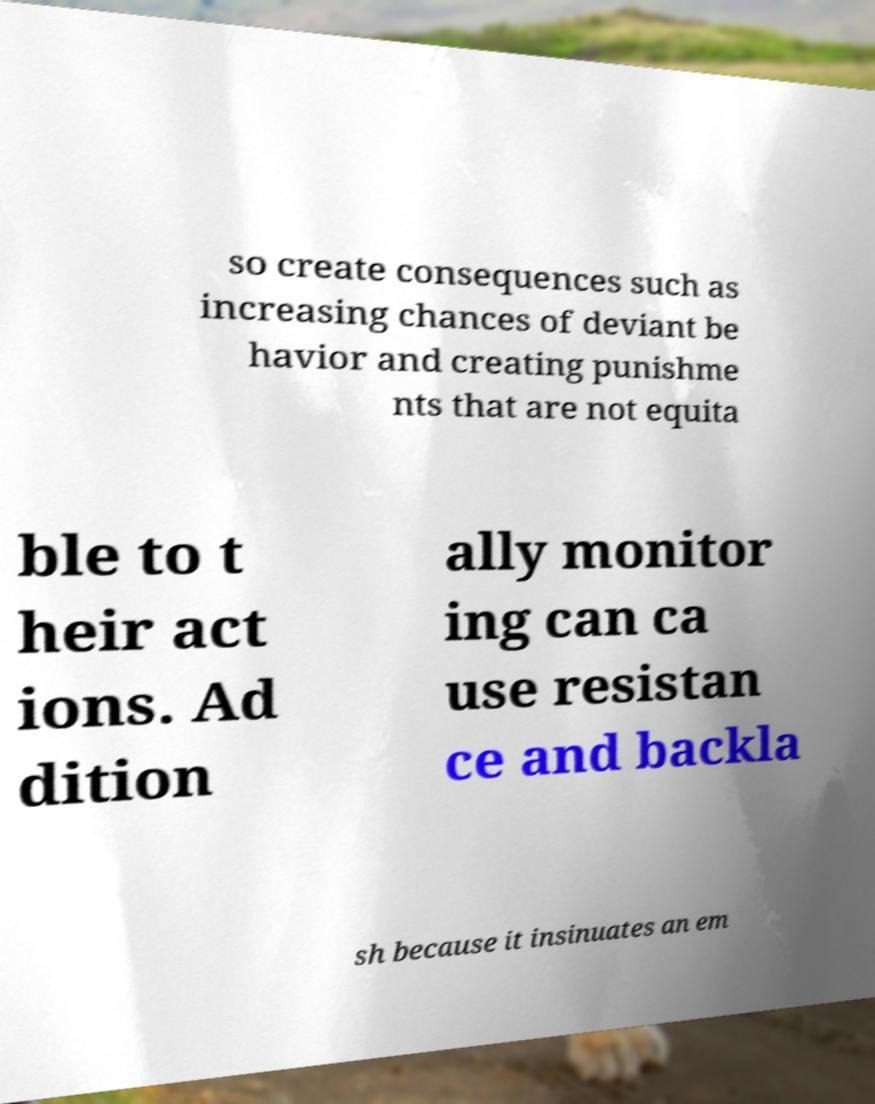There's text embedded in this image that I need extracted. Can you transcribe it verbatim? so create consequences such as increasing chances of deviant be havior and creating punishme nts that are not equita ble to t heir act ions. Ad dition ally monitor ing can ca use resistan ce and backla sh because it insinuates an em 